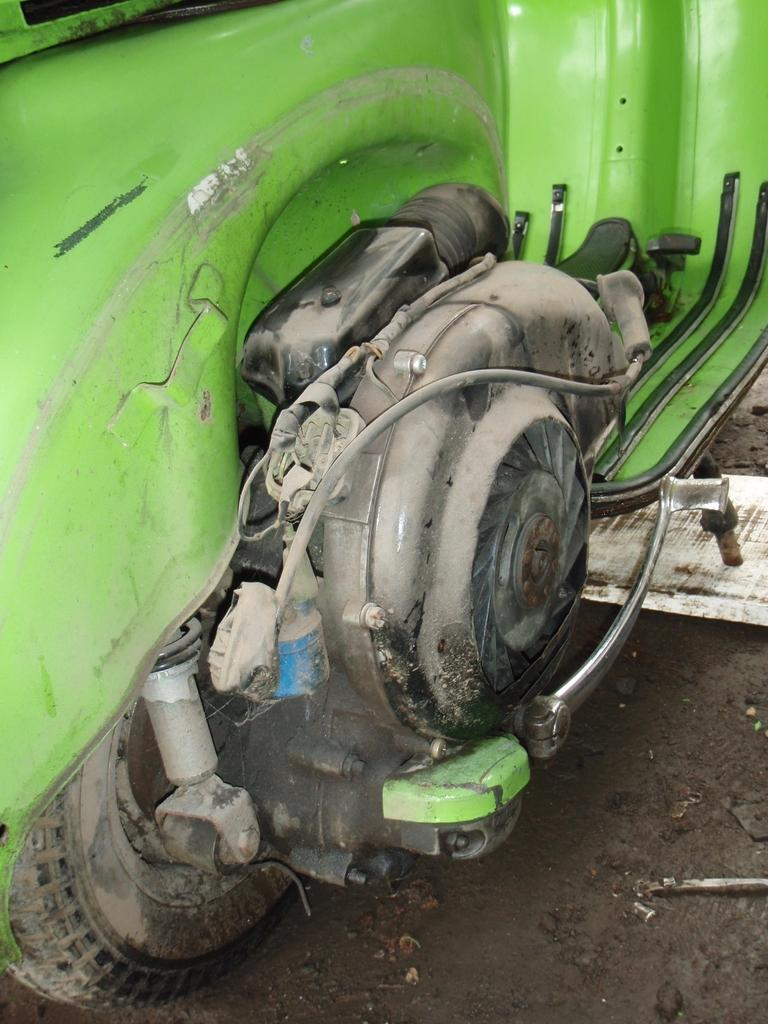What type of vehicle is in the image? There is a scooter in the image. What color is the scooter? The scooter is green in color. Can you see a horse grazing near the scooter in the image? No, there is no horse present in the image. 